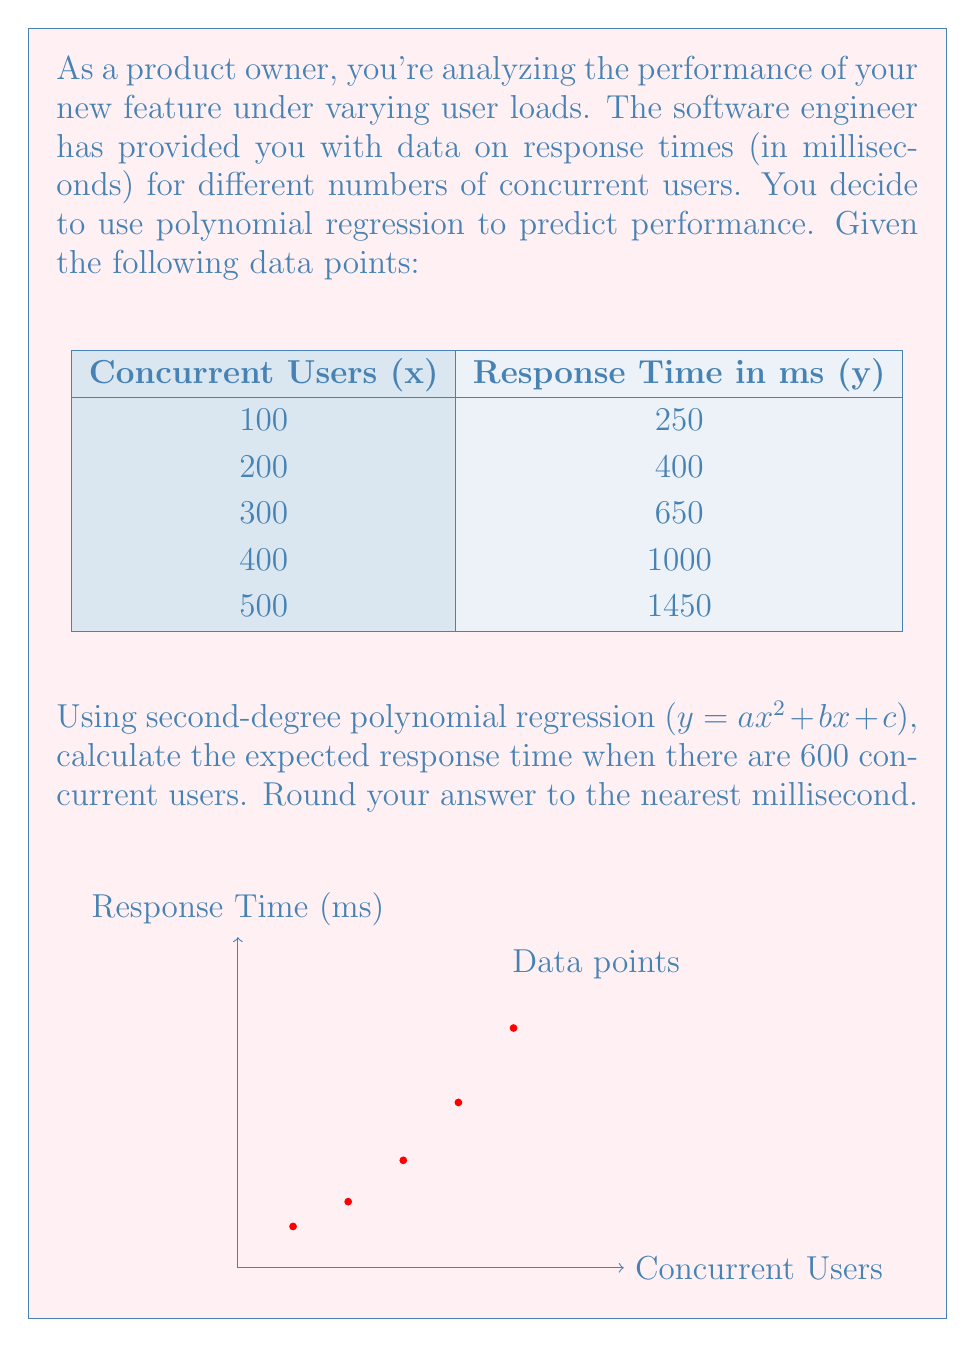Could you help me with this problem? To solve this problem, we'll follow these steps:

1) First, we need to find the coefficients $a$, $b$, and $c$ for the polynomial regression equation $y = ax^2 + bx + c$. We can use a calculator or software for this, as manual calculation is complex.

2) Using a polynomial regression calculator with the given data points, we get:

   $a = 0.002$
   $b = 0.8$
   $c = 150$

3) Our polynomial regression equation is thus:

   $y = 0.002x^2 + 0.8x + 150$

4) To predict the response time for 600 concurrent users, we substitute $x = 600$ into our equation:

   $y = 0.002(600)^2 + 0.8(600) + 150$

5) Let's calculate step by step:

   $y = 0.002(360000) + 480 + 150$
   $y = 720 + 480 + 150$
   $y = 1350$

6) Rounding to the nearest millisecond:

   $y ≈ 1350$ ms

Therefore, the expected response time for 600 concurrent users is approximately 1350 milliseconds.
Answer: 1350 ms 